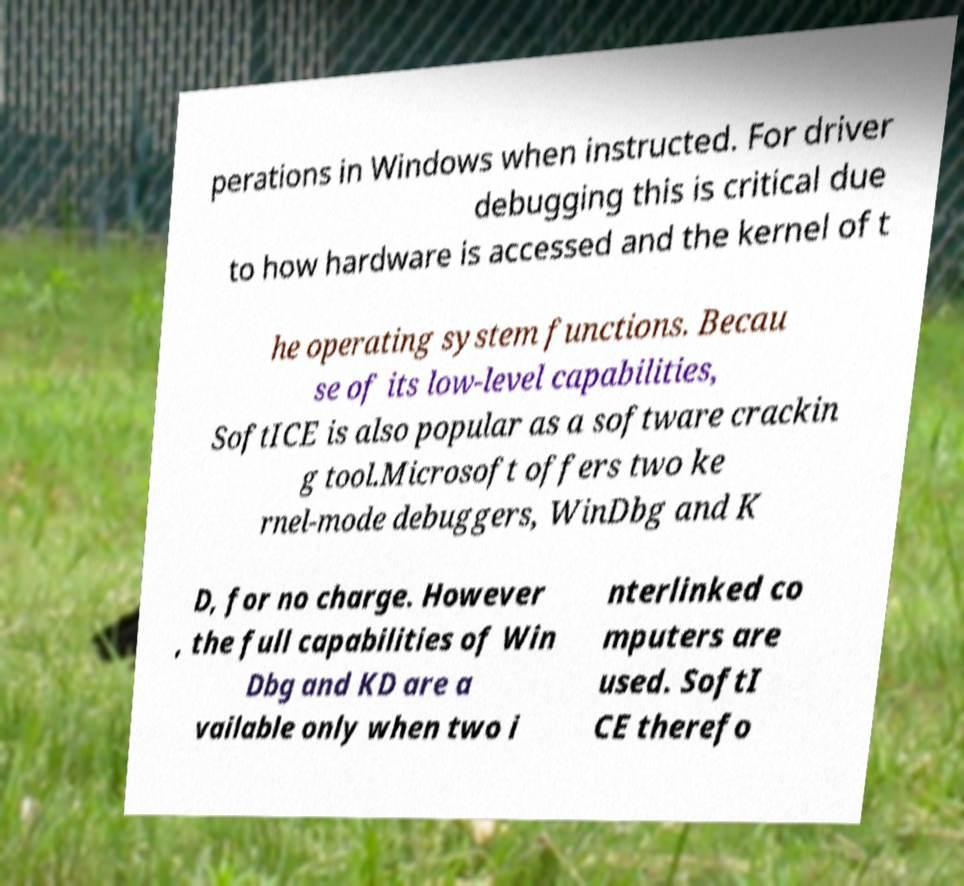I need the written content from this picture converted into text. Can you do that? perations in Windows when instructed. For driver debugging this is critical due to how hardware is accessed and the kernel of t he operating system functions. Becau se of its low-level capabilities, SoftICE is also popular as a software crackin g tool.Microsoft offers two ke rnel-mode debuggers, WinDbg and K D, for no charge. However , the full capabilities of Win Dbg and KD are a vailable only when two i nterlinked co mputers are used. SoftI CE therefo 